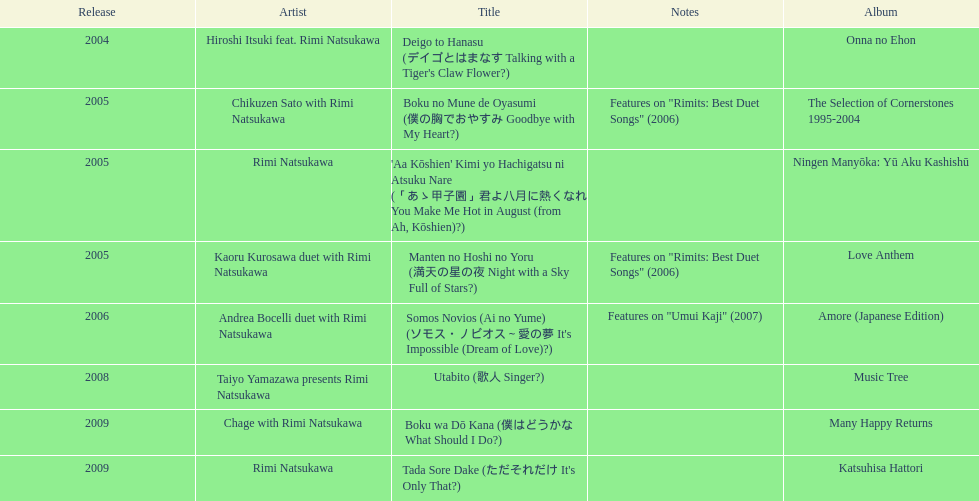What is the last title released? 2009. 